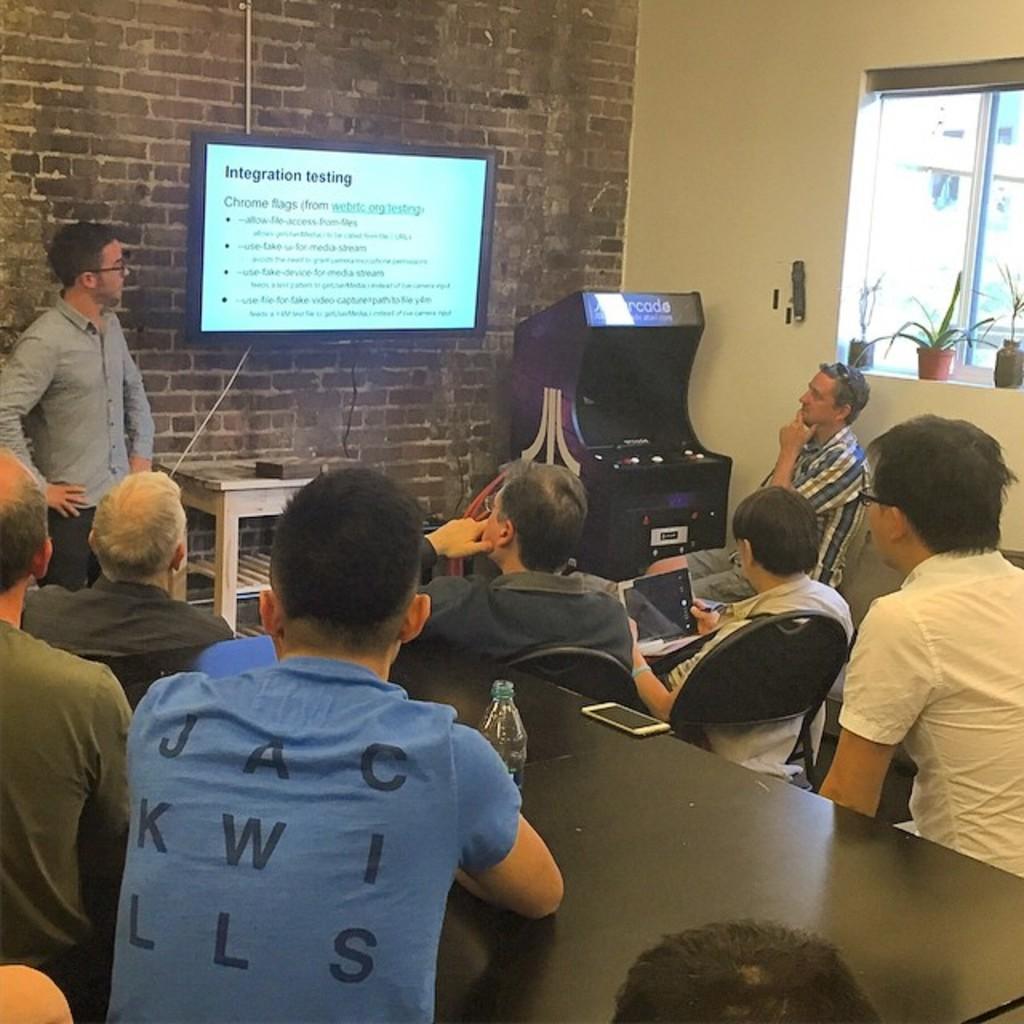Please provide a concise description of this image. There is a meeting going on,a person is standing in front of a wall and there is a screen fit on the wall and in front of the screen a group of people are sitting and watching the picture shown on the screen,in the right side there is a window and in front of the window there are three small plants. 